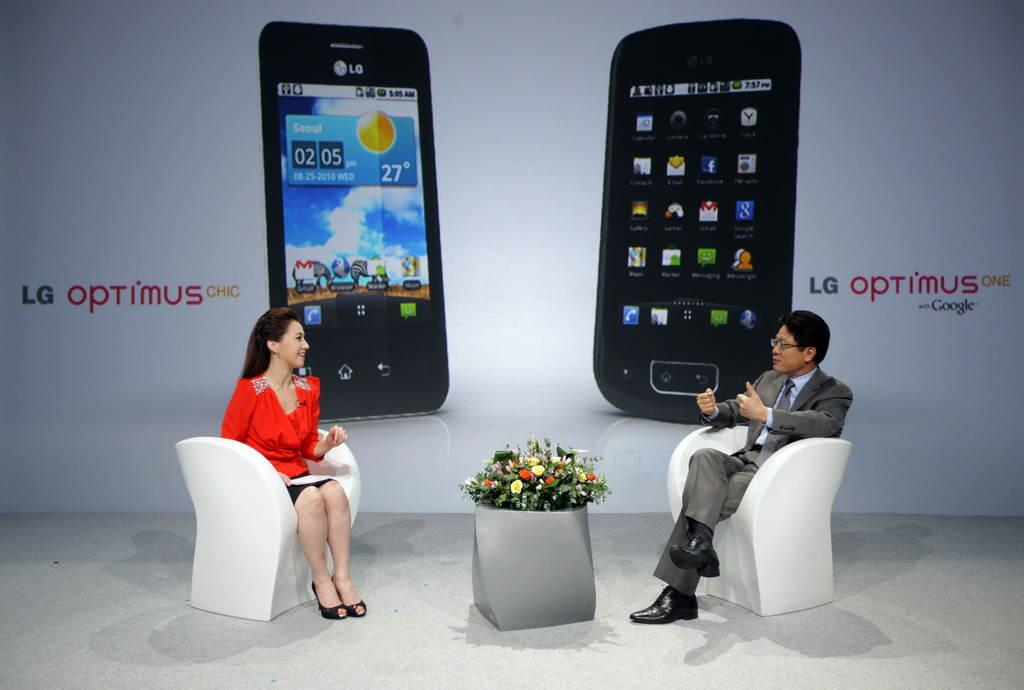Provide a one-sentence caption for the provided image. A man and woman sitting in front of an ad for a cell phone. 